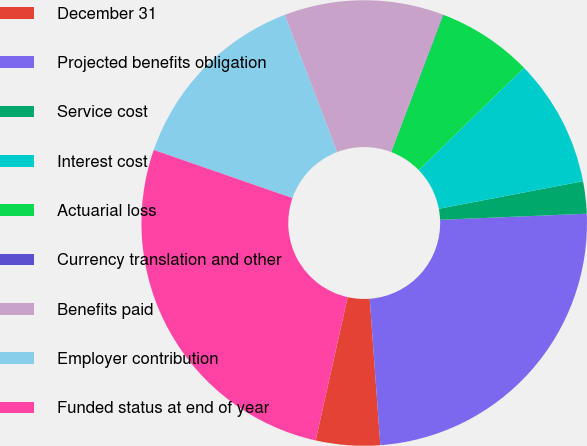<chart> <loc_0><loc_0><loc_500><loc_500><pie_chart><fcel>December 31<fcel>Projected benefits obligation<fcel>Service cost<fcel>Interest cost<fcel>Actuarial loss<fcel>Currency translation and other<fcel>Benefits paid<fcel>Employer contribution<fcel>Funded status at end of year<nl><fcel>4.65%<fcel>24.51%<fcel>2.34%<fcel>9.26%<fcel>6.95%<fcel>0.03%<fcel>11.56%<fcel>13.87%<fcel>26.82%<nl></chart> 